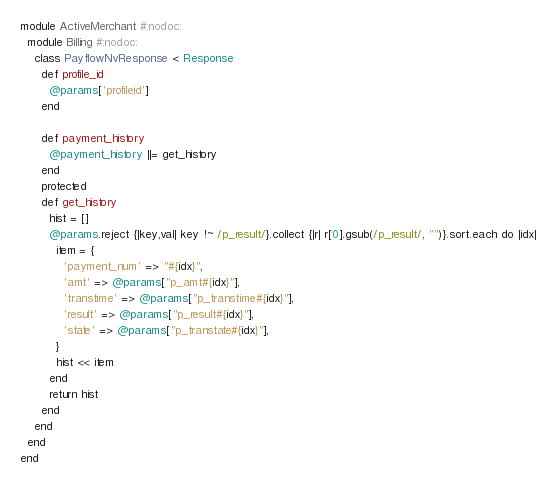Convert code to text. <code><loc_0><loc_0><loc_500><loc_500><_Ruby_>module ActiveMerchant #:nodoc:
  module Billing #:nodoc:
    class PayflowNvResponse < Response
      def profile_id
        @params['profileid']
      end

      def payment_history
        @payment_history ||= get_history
      end
      protected
      def get_history
        hist = []
        @params.reject {|key,val| key !~ /p_result/}.collect {|r| r[0].gsub(/p_result/, "")}.sort.each do |idx|
          item = {
            'payment_num' => "#{idx}",
            'amt' => @params["p_amt#{idx}"],
            'transtime' => @params["p_transtime#{idx}"],
            'result' => @params["p_result#{idx}"],
            'state' => @params["p_transtate#{idx}"],
          }
          hist << item
        end
        return hist
      end
    end
  end
end
</code> 